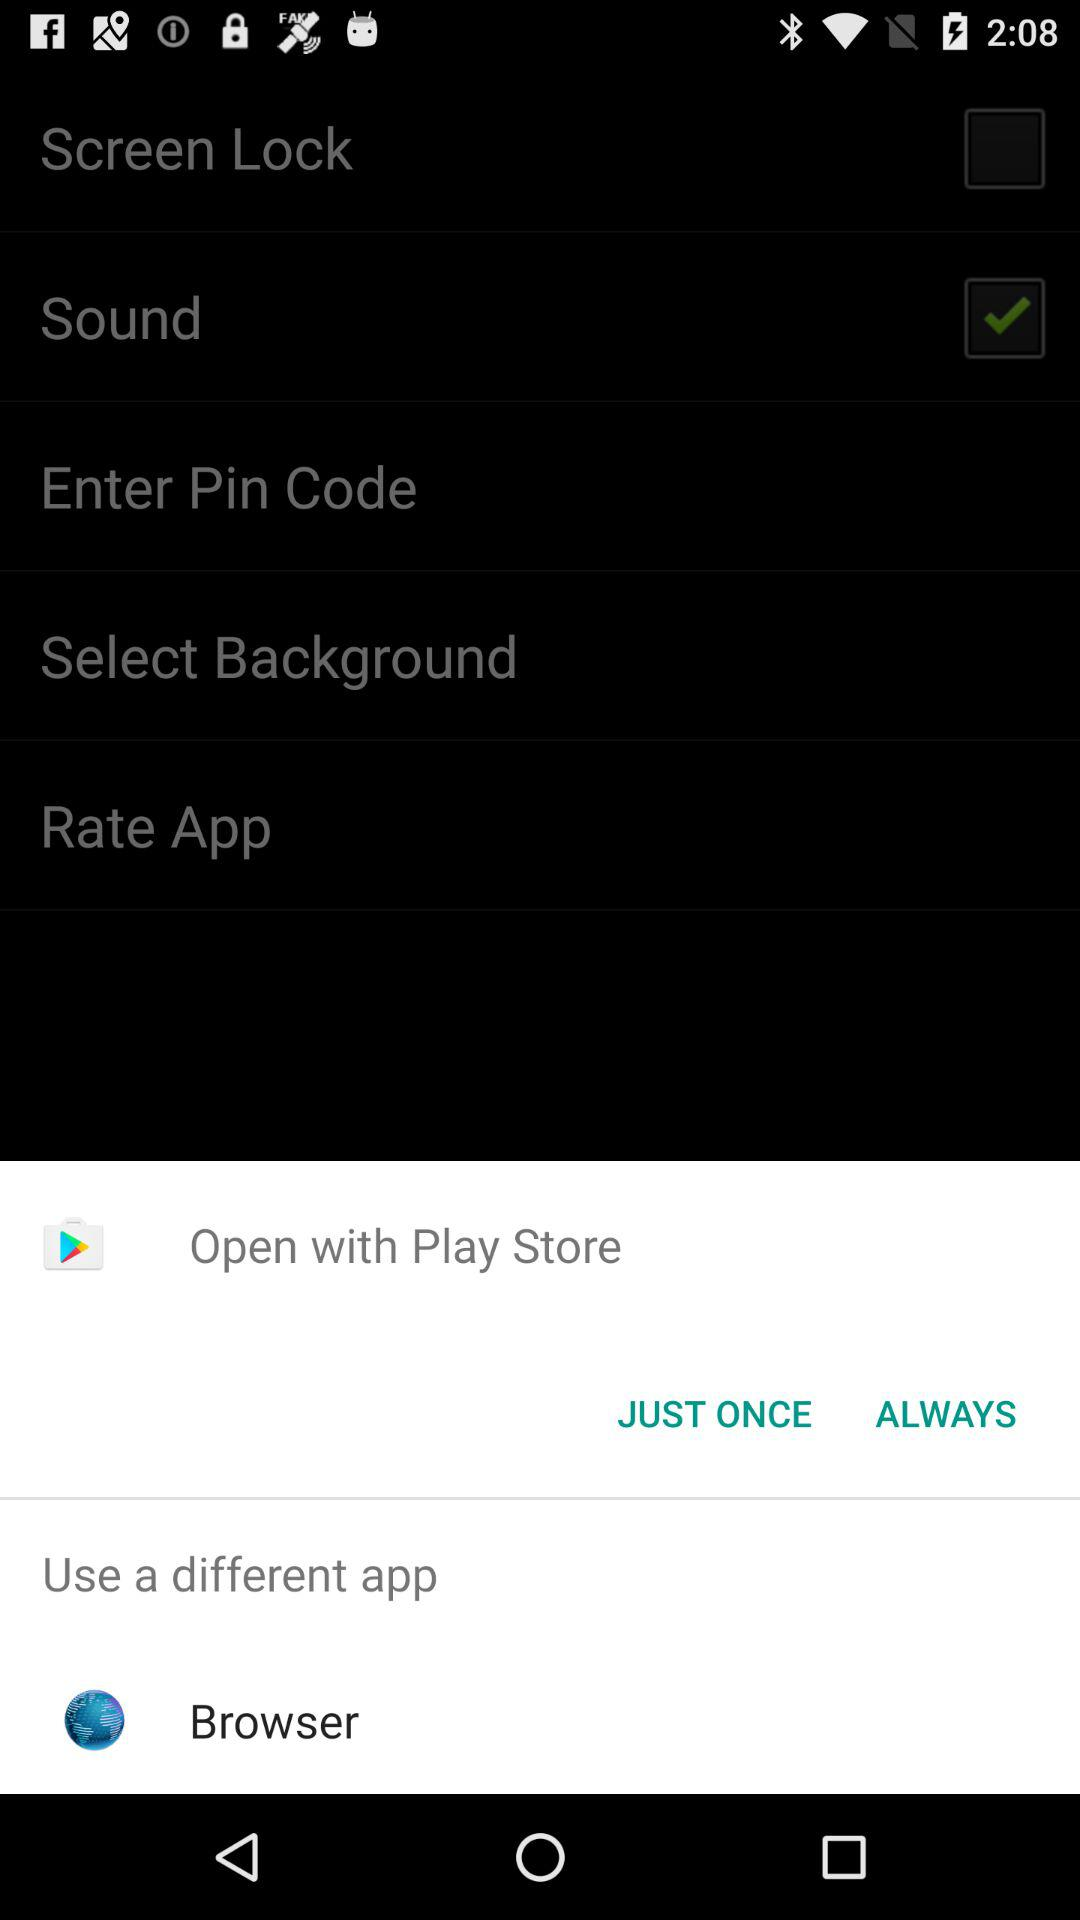What is the current status of "Screen Lock"? The status is "off". 